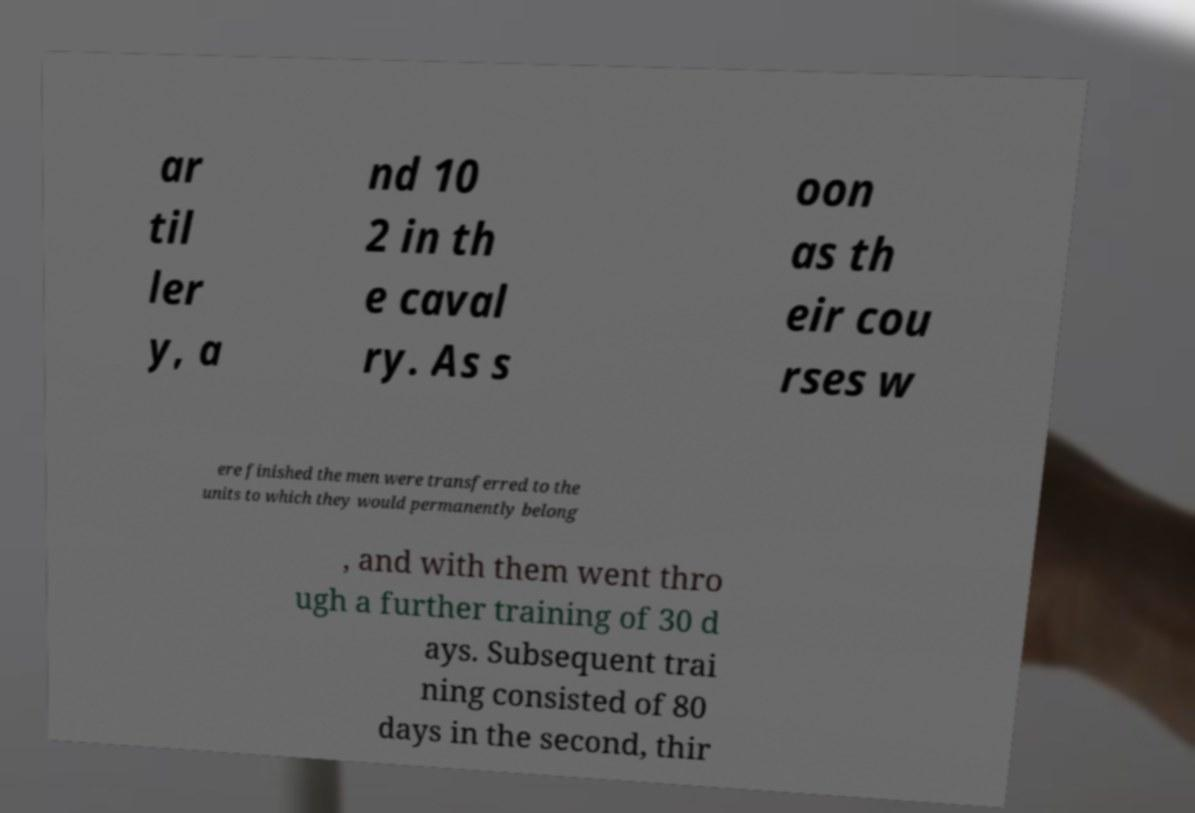Could you assist in decoding the text presented in this image and type it out clearly? ar til ler y, a nd 10 2 in th e caval ry. As s oon as th eir cou rses w ere finished the men were transferred to the units to which they would permanently belong , and with them went thro ugh a further training of 30 d ays. Subsequent trai ning consisted of 80 days in the second, thir 